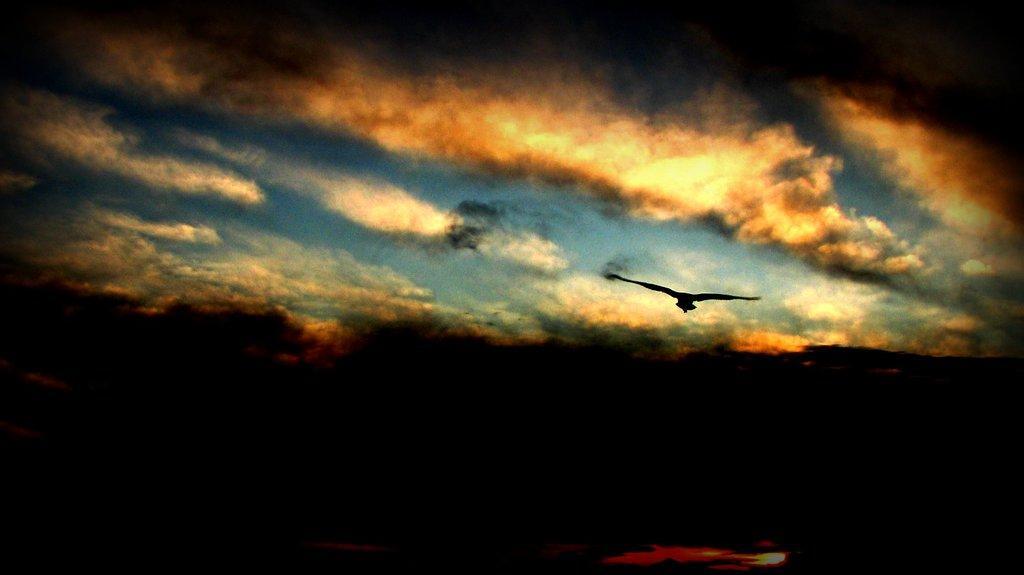How would you summarize this image in a sentence or two? In the picture I can see a bird is flying in the air. In the background I can see the sky. This image is little bit dark. 